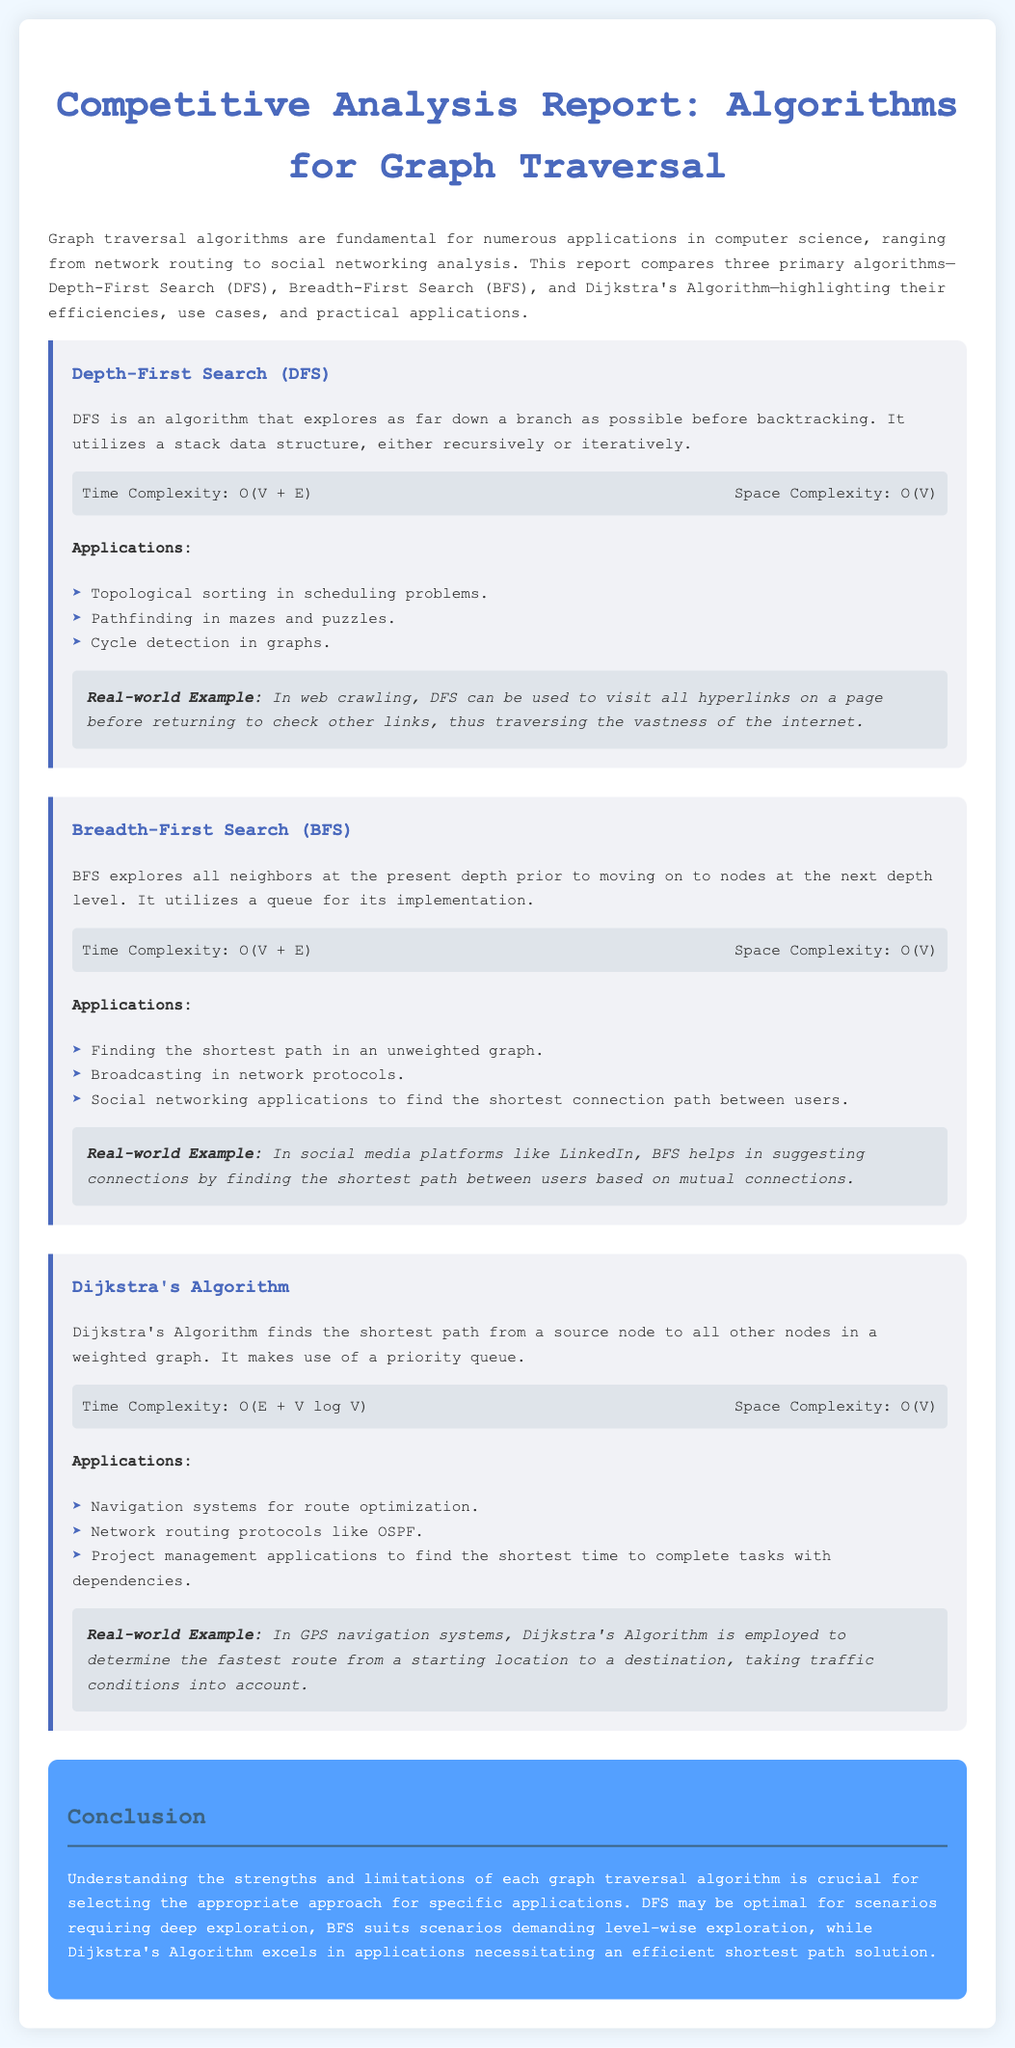What are the three primary algorithms compared in this report? The report compares Depth-First Search (DFS), Breadth-First Search (BFS), and Dijkstra's Algorithm.
Answer: DFS, BFS, Dijkstra's Algorithm What is the time complexity of Depth-First Search (DFS)? The time complexity for DFS is noted in the document as O(V + E).
Answer: O(V + E) Which algorithm is used for finding the shortest path in an unweighted graph? The document states that Breadth-First Search (BFS) is used for this purpose.
Answer: Breadth-First Search (BFS) What data structure does Dijkstra's Algorithm use? The report specifies that Dijkstra's Algorithm makes use of a priority queue.
Answer: Priority queue In what real-world application is BFS exemplified? The provided example mentions social media platforms like LinkedIn for suggesting connections.
Answer: LinkedIn What is the space complexity of Dijkstra's Algorithm? The document states the space complexity of Dijkstra's Algorithm is O(V).
Answer: O(V) What does the conclusion emphasize regarding algorithm selection? The conclusion highlights the importance of understanding strengths and limitations for selecting the right algorithm.
Answer: Understanding strengths and limitations Which algorithm is suitable for deep exploration? The report suggests that Depth-First Search (DFS) is optimal for scenarios requiring deep exploration.
Answer: Depth-First Search (DFS) 